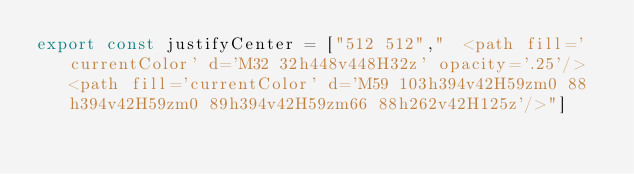<code> <loc_0><loc_0><loc_500><loc_500><_JavaScript_>export const justifyCenter = ["512 512","  <path fill='currentColor' d='M32 32h448v448H32z' opacity='.25'/>  <path fill='currentColor' d='M59 103h394v42H59zm0 88h394v42H59zm0 89h394v42H59zm66 88h262v42H125z'/>"]</code> 